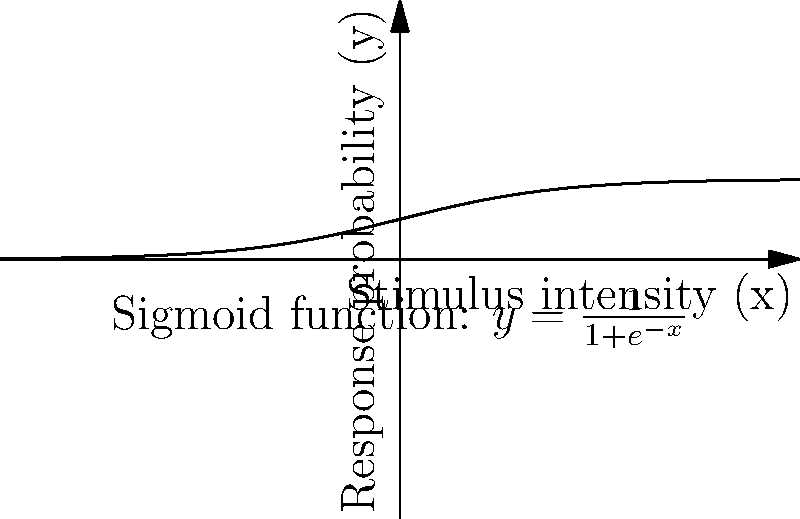In ecological studies, researchers often use logistic regression to model the relationship between environmental factors and species occurrence. The graph shows a sigmoid function commonly used in logistic regression. How would you interpret this function in the context of analyzing the impact of a specific environmental variable (x) on the probability of a species' presence (y) in a given habitat? To interpret the logistic regression function in this ecological context, we can follow these steps:

1. Identify the function: The sigmoid function shown is the logistic function, given by:

   $$y = \frac{1}{1+e^{-x}}$$

2. Understand the axes:
   - x-axis: Represents the environmental variable (stimulus intensity)
   - y-axis: Represents the probability of species presence (response probability)

3. Interpret the shape:
   - The function is S-shaped, bounded between 0 and 1
   - This shape indicates a non-linear relationship between x and y

4. Analyze the curve's behavior:
   - As x approaches negative infinity, y approaches 0
   - As x approaches positive infinity, y approaches 1
   - The steepest part of the curve is around x = 0

5. Ecological interpretation:
   - When the environmental variable (x) is very low, the probability of species presence (y) is close to 0
   - As the environmental variable increases, the probability of species presence increases
   - The rate of increase is highest around the middle of the range (inflection point)
   - At high values of the environmental variable, the probability of species presence approaches 1

6. Practical application:
   - This model can help predict how changes in the environmental variable affect the likelihood of finding the species in a given habitat
   - It can be used to identify critical thresholds or ranges of the environmental variable that significantly impact species presence
Answer: The sigmoid function models a non-linear relationship where species presence probability increases with the environmental variable, with the steepest increase around the middle range and approaching limits of 0 and 1 at extreme values. 